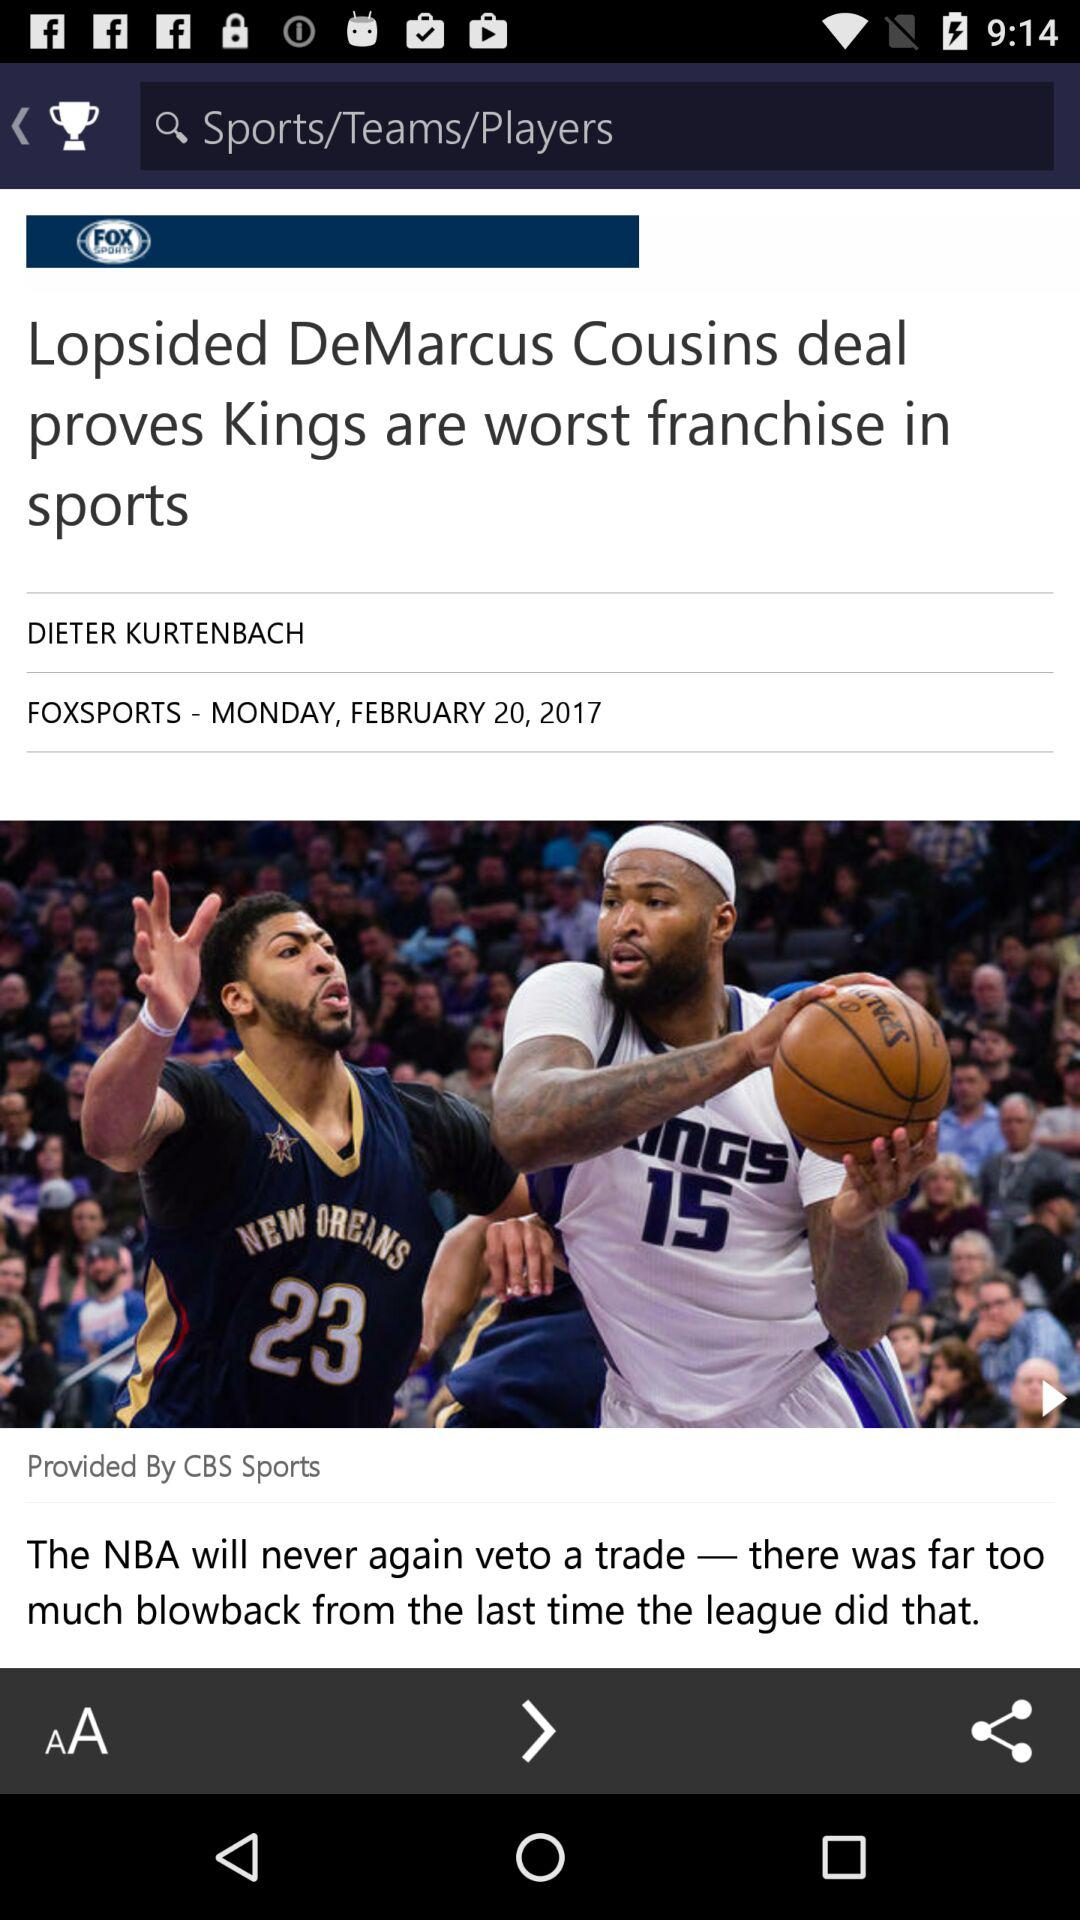What is the title of the article? The title of the article is "Lopsided DeMarcus Cousins deal proves Kings are worst franchise in sports". 